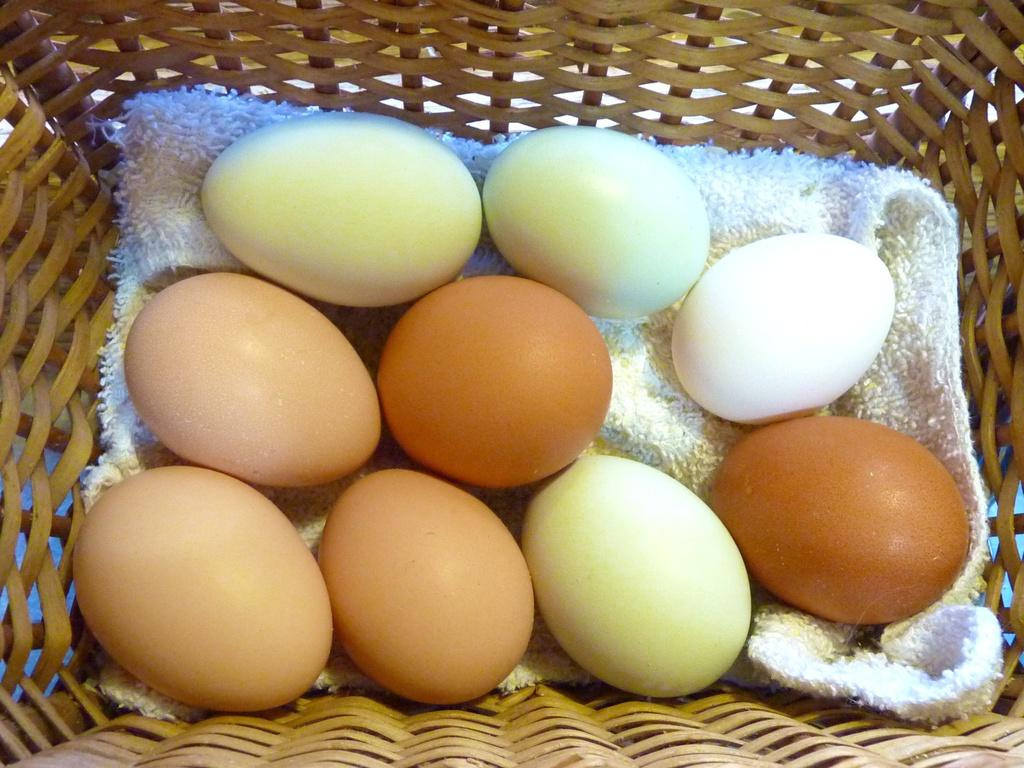What object is present in the image that can hold items? There is a basket in the image. What is inside the basket? There are eggs in the basket. How are the eggs placed in the basket? The eggs are kept on a cloth. How much debt is owed by the horn in the image? There is no horn present in the image, so the concept of debt does not apply. 